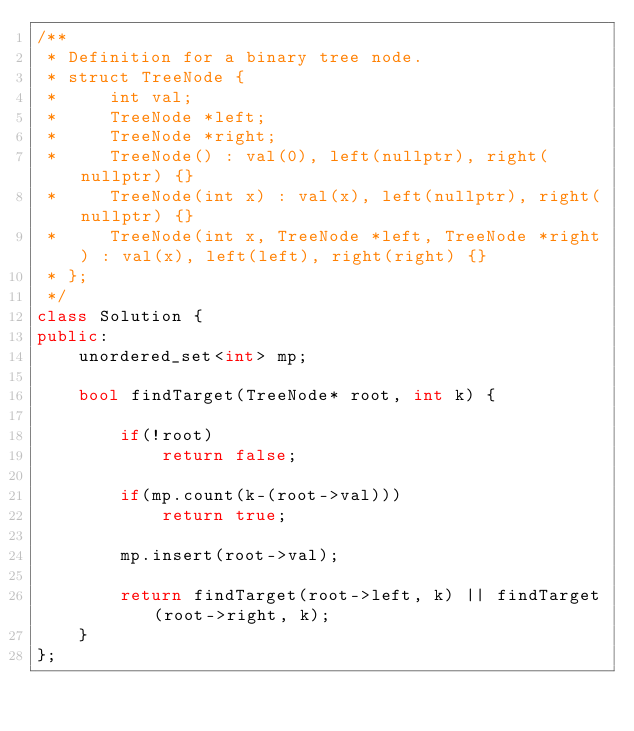<code> <loc_0><loc_0><loc_500><loc_500><_C++_>/**
 * Definition for a binary tree node.
 * struct TreeNode {
 *     int val;
 *     TreeNode *left;
 *     TreeNode *right;
 *     TreeNode() : val(0), left(nullptr), right(nullptr) {}
 *     TreeNode(int x) : val(x), left(nullptr), right(nullptr) {}
 *     TreeNode(int x, TreeNode *left, TreeNode *right) : val(x), left(left), right(right) {}
 * };
 */
class Solution {
public:
    unordered_set<int> mp;
    
    bool findTarget(TreeNode* root, int k) {
        
        if(!root)
            return false;
        
        if(mp.count(k-(root->val)))
            return true;
        
        mp.insert(root->val);
        
        return findTarget(root->left, k) || findTarget(root->right, k);
    }
};</code> 